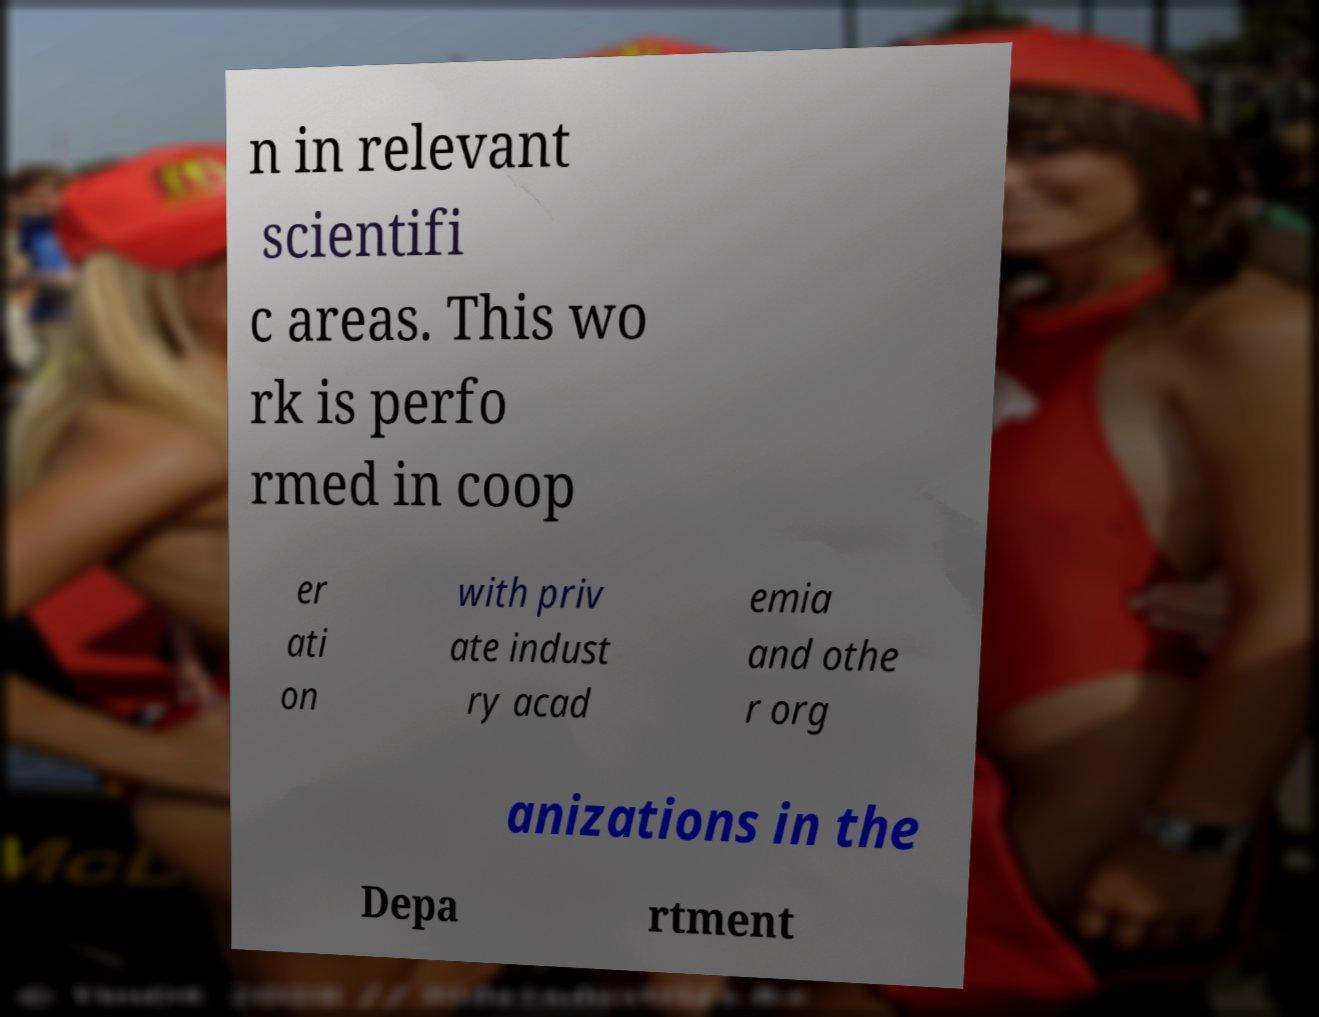Could you extract and type out the text from this image? n in relevant scientifi c areas. This wo rk is perfo rmed in coop er ati on with priv ate indust ry acad emia and othe r org anizations in the Depa rtment 